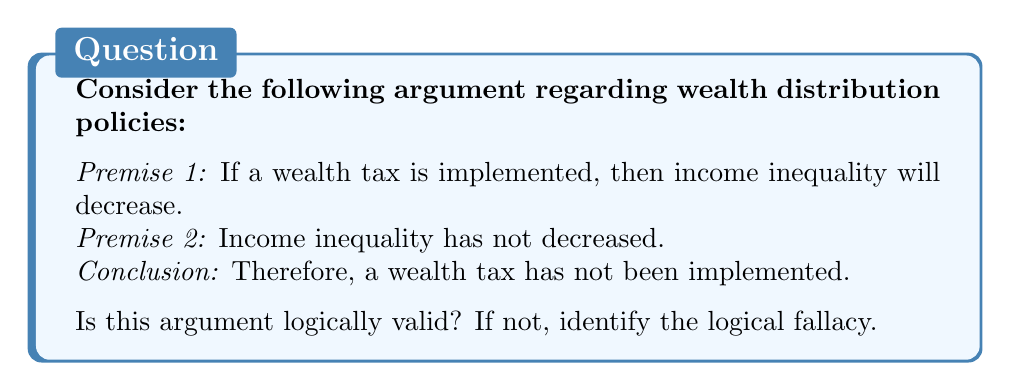Solve this math problem. To determine the logical validity of this argument, we need to analyze its structure and compare it to valid logical forms. Let's break it down:

1. Let $p$ represent "a wealth tax is implemented"
2. Let $q$ represent "income inequality will decrease"

We can rewrite the argument in symbolic form:

Premise 1: $p \rightarrow q$ (If $p$, then $q$)
Premise 2: $\neg q$ (Not $q$)
Conclusion: $\neg p$ (Therefore, not $p$)

This argument form is known as denying the consequent or modus tollens inverse. It can be represented as:

$$ \frac{p \rightarrow q, \quad \neg q}{\therefore \neg p} $$

This form is not logically valid. It commits the fallacy of denying the consequent.

To understand why this is a fallacy, let's consider the truth table for the implication $p \rightarrow q$:

$$
\begin{array}{|c|c|c|}
\hline
p & q & p \rightarrow q \\
\hline
T & T & T \\
T & F & F \\
F & T & T \\
F & F & T \\
\hline
\end{array}
$$

The fallacy occurs because when $q$ is false (as stated in Premise 2), $p$ could be either true or false without contradicting the implication $p \rightarrow q$. Therefore, we cannot validly conclude that $p$ must be false.

In the context of the wealth distribution policy argument, just because income inequality has not decreased doesn't necessarily mean that a wealth tax hasn't been implemented. There could be other factors affecting income inequality, or the wealth tax might not have had the expected effect.

A logically valid form of this argument would be modus tollens:

$$ \frac{p \rightarrow q, \quad \neg q}{\therefore \neg p} $$

But this would require the first premise to be "If income inequality has not decreased, then a wealth tax has not been implemented," which is different from the given premise.
Answer: The argument is not logically valid. It commits the fallacy of denying the consequent. 